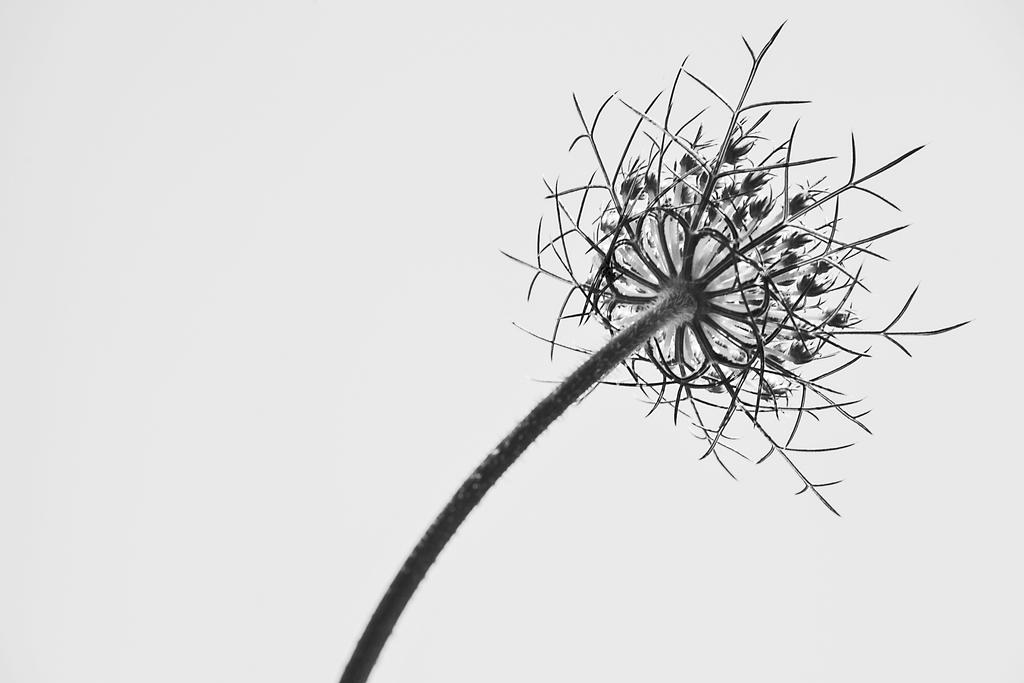What is the main subject of the image? There is a flower in the middle of the image. What is the color of the flower? The color of the flower is not mentioned in the facts. What type of beast can be seen interacting with the flower in the image? There is no beast present in the image, and therefore no such interaction can be observed. 